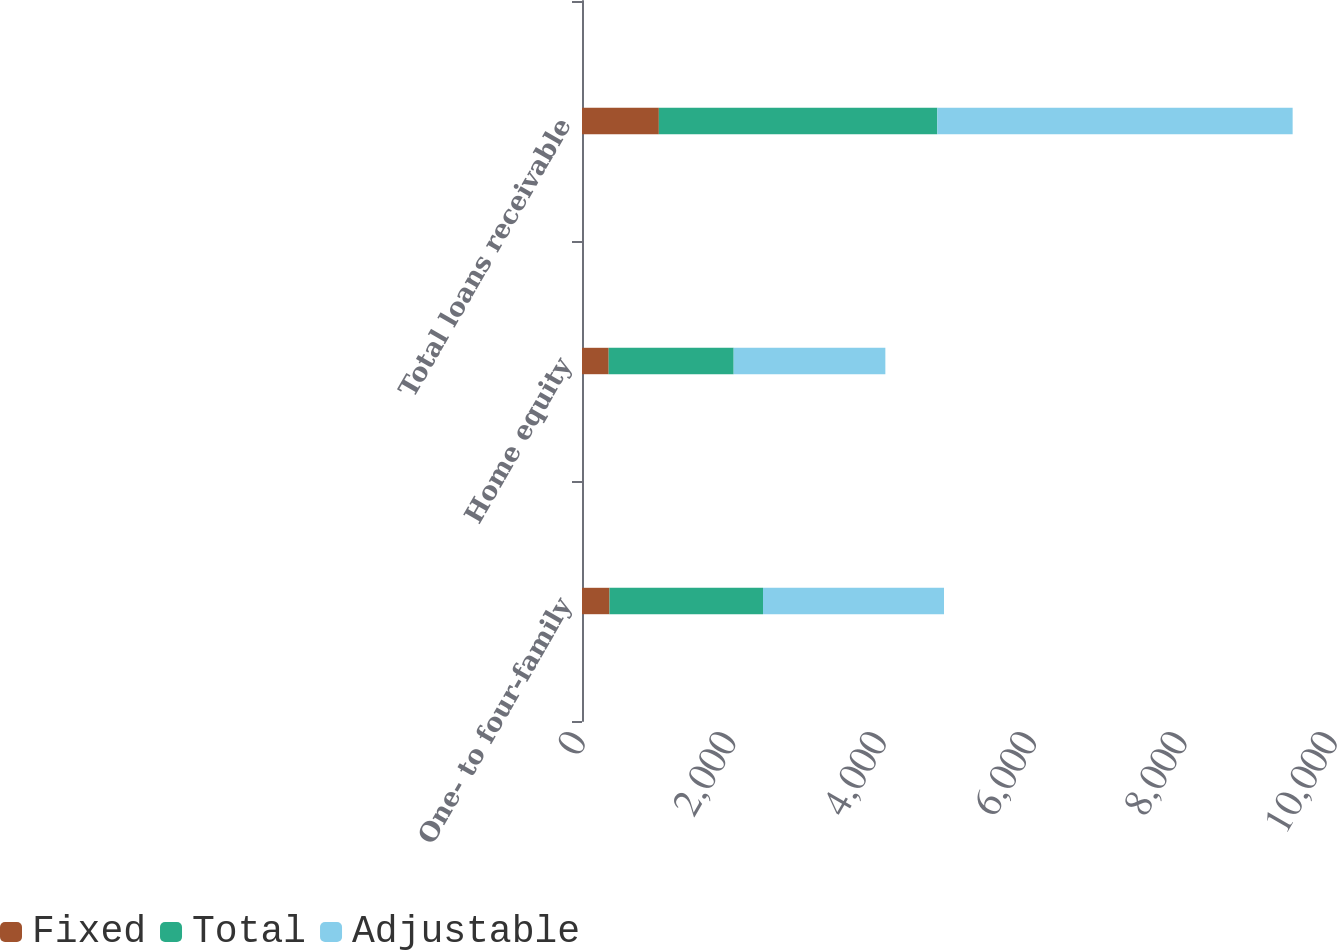Convert chart to OTSL. <chart><loc_0><loc_0><loc_500><loc_500><stacked_bar_chart><ecel><fcel>One- to four-family<fcel>Home equity<fcel>Total loans receivable<nl><fcel>Fixed<fcel>366<fcel>355<fcel>1022<nl><fcel>Total<fcel>2041<fcel>1662<fcel>3703<nl><fcel>Adjustable<fcel>2407<fcel>2017<fcel>4725<nl></chart> 